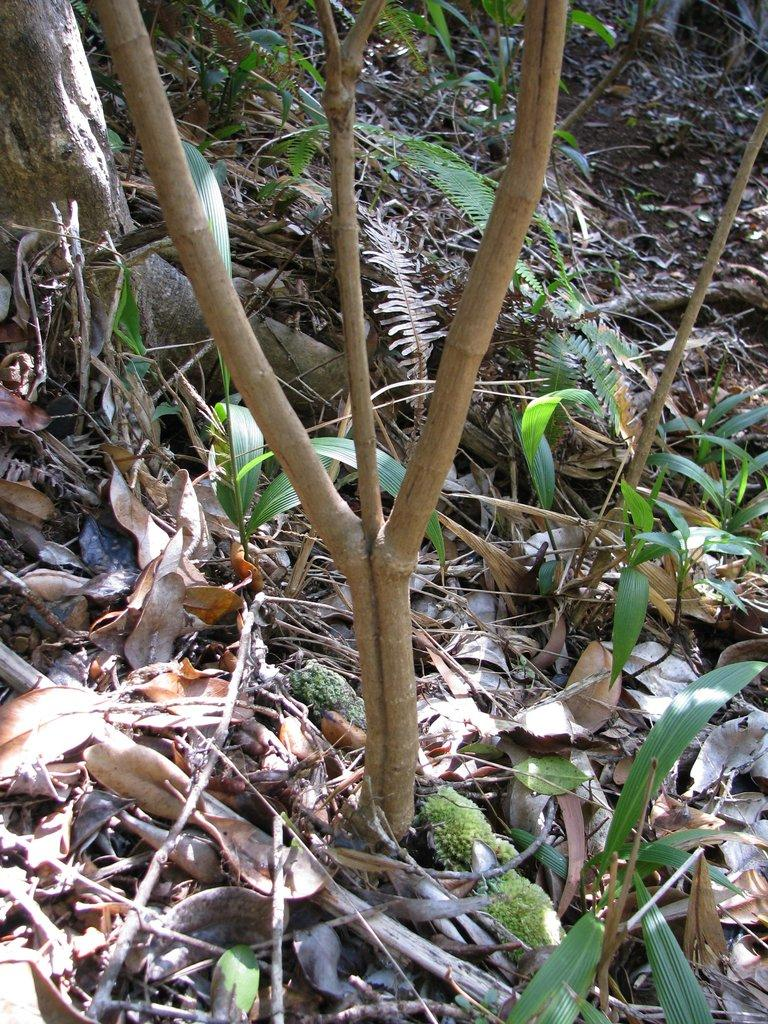What type of vegetation can be seen in the image? There are trees and plants in the image. What can be found on the ground in the image? Dried leaves and sticks are present on the ground. What type of reward is being given to the plants in the image? There is no reward being given to the plants in the image; the image simply shows trees and plants in their natural state. 